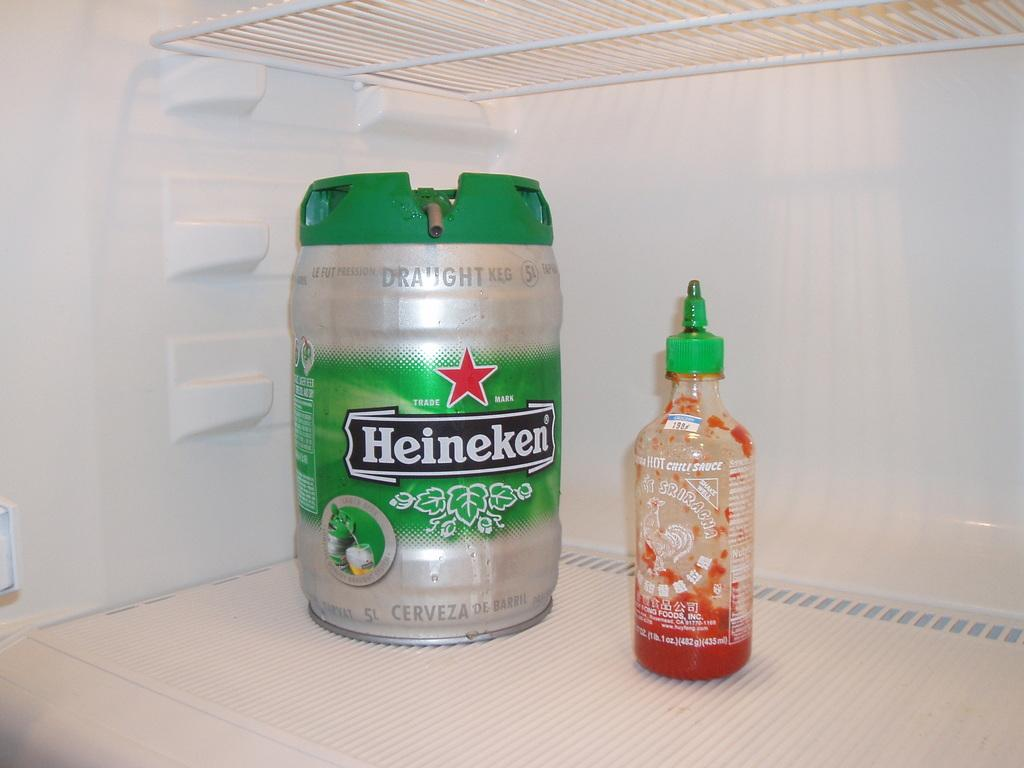What type of container is in the fridge? There is a tin in the fridge. What else can be found in the fridge? There is a bottle in the fridge. Where is the kettle located in the image? There is no kettle present in the image. What type of musical instrument is being played in the image? There is no musical instrument being played in the image. 